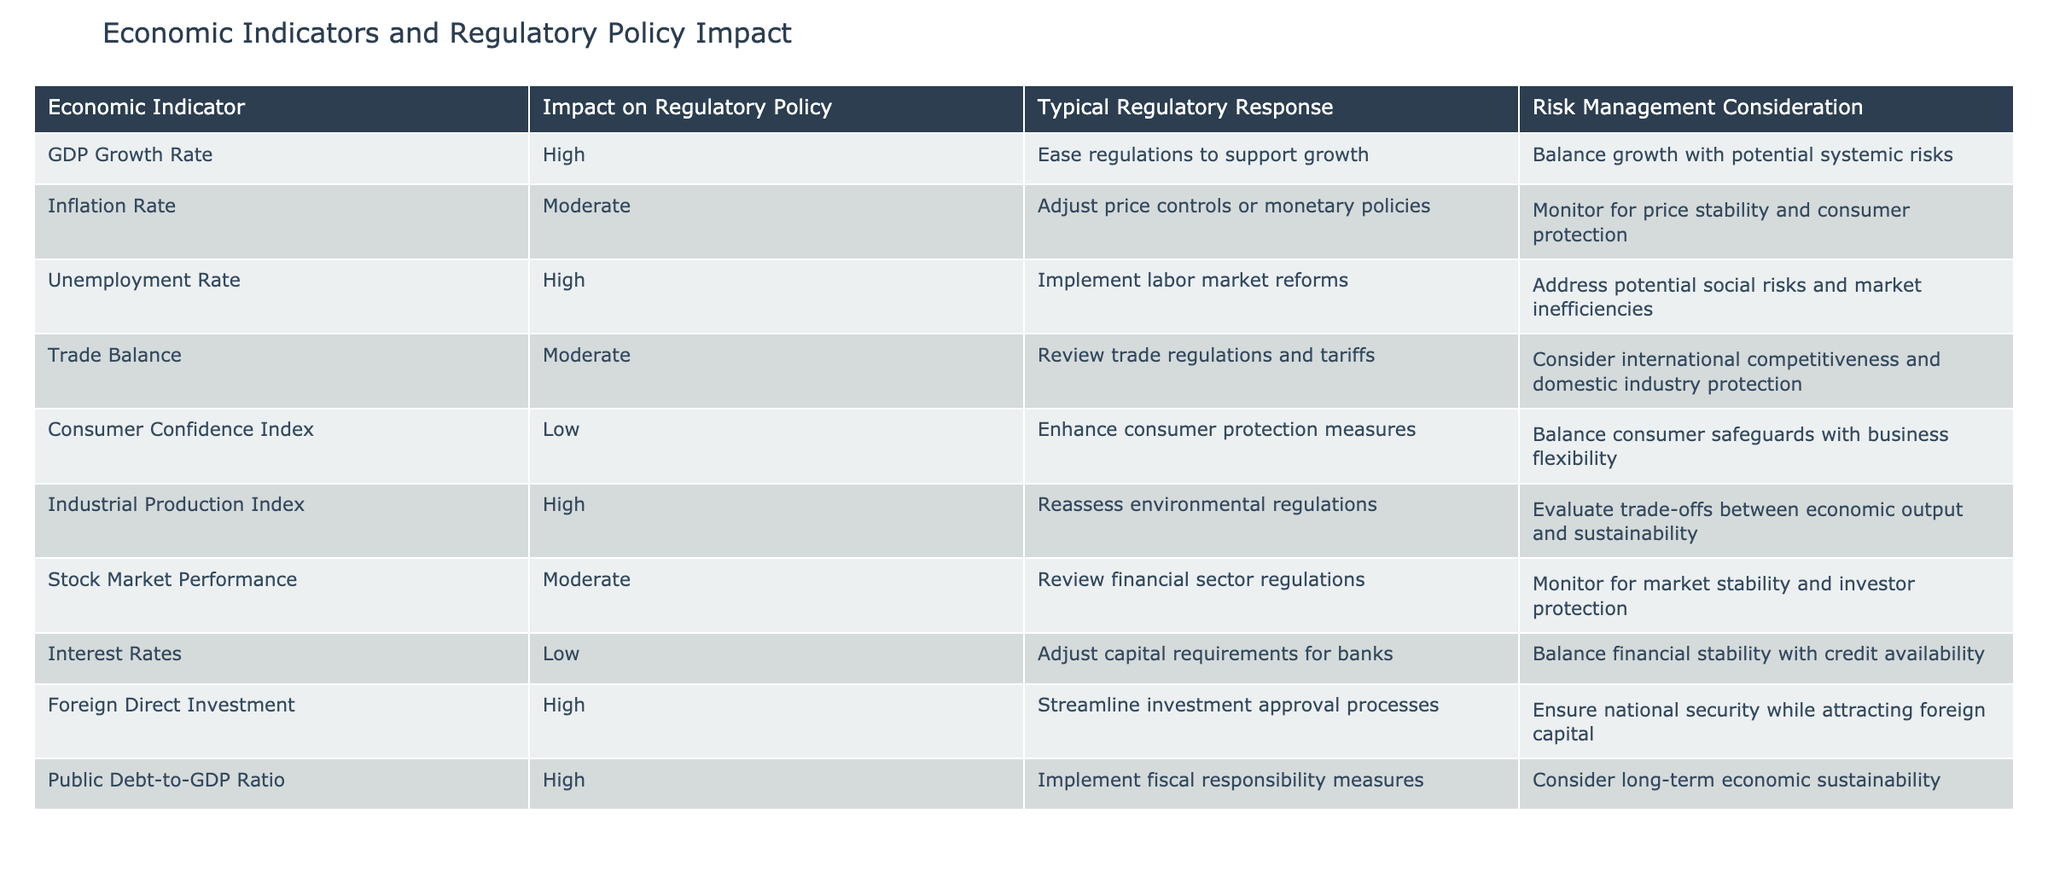What is the impact of the GDP Growth Rate on regulatory policy? The table indicates that the impact of the GDP Growth Rate on regulatory policy is categorized as "High." This can be directly retrieved from the corresponding column related to the GDP Growth Rate.
Answer: High Which regulatory response is typical for a high Unemployment Rate? The table shows that for a high Unemployment Rate, the typical regulatory response is to implement labor market reforms. This is mentioned directly in the row for the Unemployment Rate.
Answer: Implement labor market reforms How many economic indicators have a moderate impact on regulatory policy decisions? Looking at the table, there are two indicators listed with a moderate impact: the Inflation Rate and Trade Balance. Thus, we can count these indicators directly from the "Impact on Regulatory Policy" column.
Answer: 2 Is the typical regulatory response for a high Foreign Direct Investment to ease regulations? The table indicates that the typical regulatory response for high Foreign Direct Investment is to streamline investment approval processes, not to ease regulations. Thus, this statement is false based on the data provided.
Answer: No What is the difference between the number of high-impact indicators and low-impact indicators? The table lists five economic indicators with a high impact (GDP Growth Rate, Unemployment Rate, Industrial Production Index, Foreign Direct Investment, and Public Debt-to-GDP Ratio) and three with a low impact (Consumer Confidence Index, Interest Rates, and Stock Market Performance). The difference is calculated as 5 - 3 = 2.
Answer: 2 What is the average impact level of all the economic indicators listed? The table categorizes impact levels as high, moderate, and low. Assigning values (high=3, moderate=2, low=1) gives us: 5 high (3) + 3 moderate (2) + 3 low (1) = 15. There are 11 indicators total, making the average (15/11) approximately 1.36, which corresponds to a moderate overall impact when using the assigned values.
Answer: Moderate Is it true that industrial production has a high impact on regulatory policies? The table states that the Industrial Production Index indeed has a high impact on regulatory policy. This is a verification of fact based on the data presented.
Answer: Yes Which economic indicator typically has a regulatory response of adjusting price controls or monetary policies? From the table, the Inflation Rate is indicated as having the typical regulatory response of adjusting price controls or monetary policies. This is easily found in the relevant row for the Inflation Rate.
Answer: Inflation Rate 